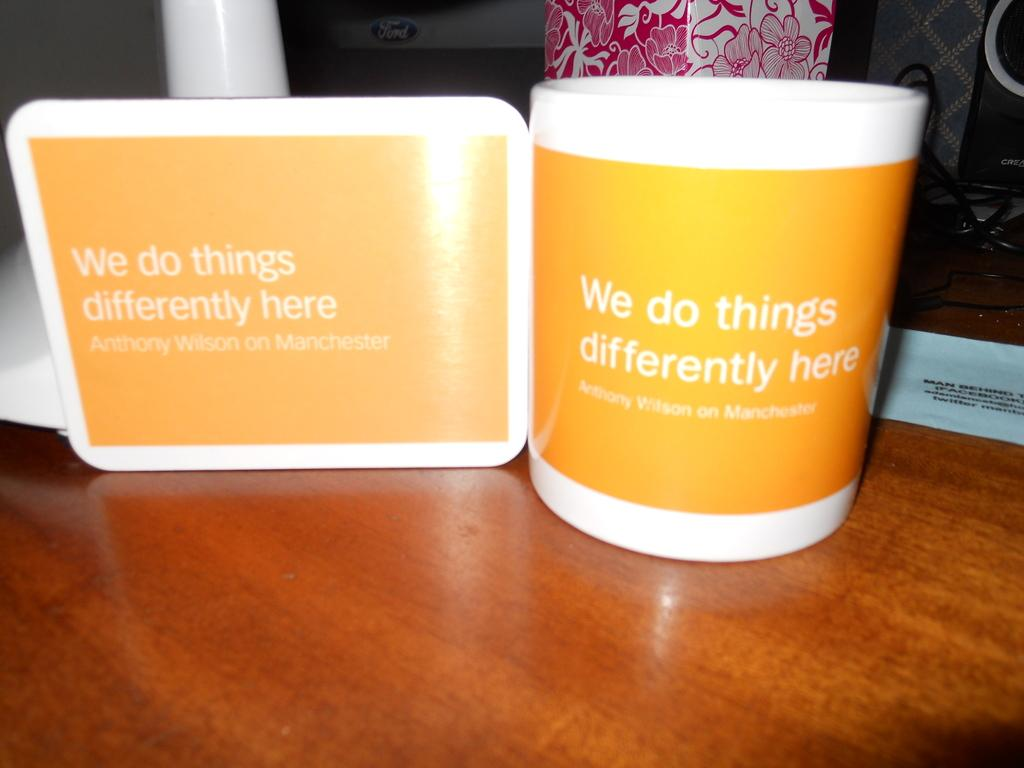<image>
Share a concise interpretation of the image provided. white mug and white card both with yellow square with words "we do things differently here anthony wilson on manchester" in white lettering 